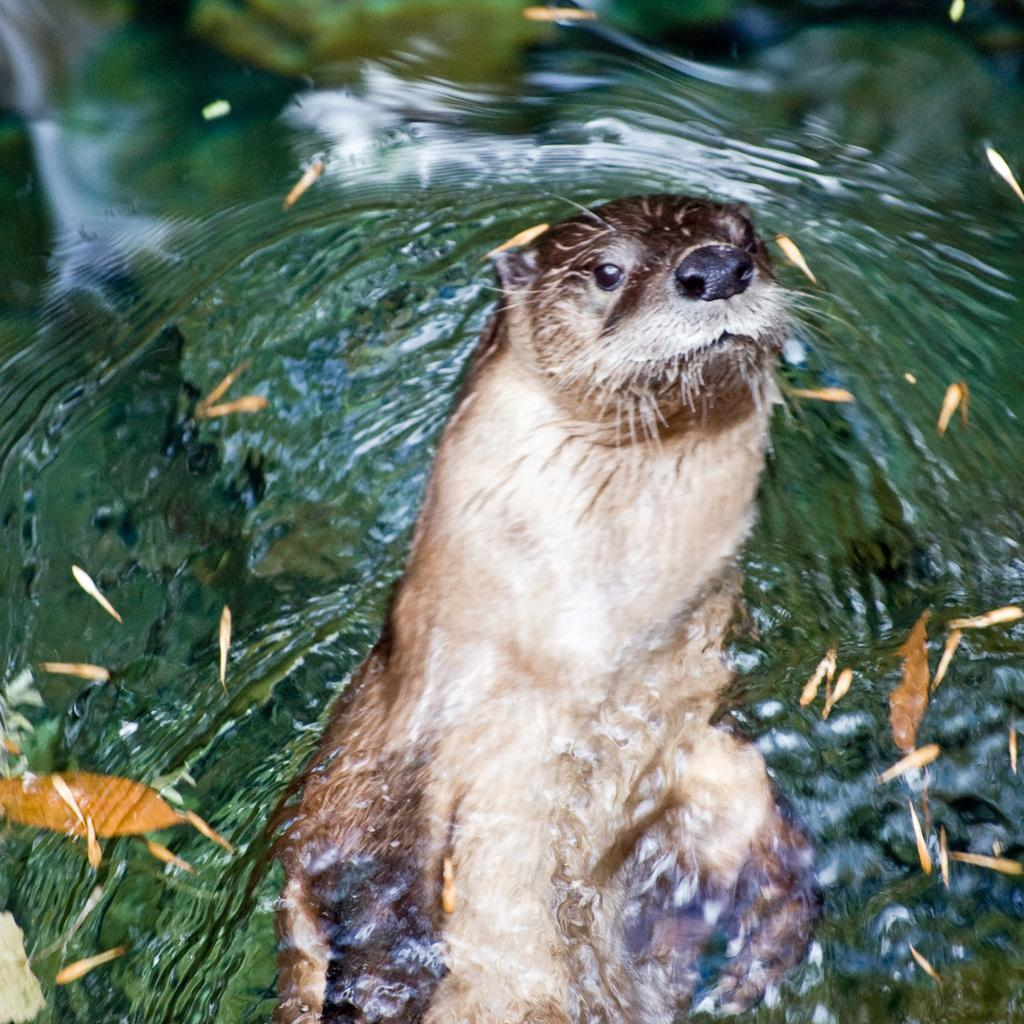What is the animal doing in the image? The animal is in the water. Can you describe any objects that are visible in the image? Unfortunately, the provided facts do not give any specific details about the objects in the image. What type of wire is being used to stitch the toys together in the image? There is no mention of toys, wire, or stitching in the provided facts, so we cannot answer this question based on the image. 